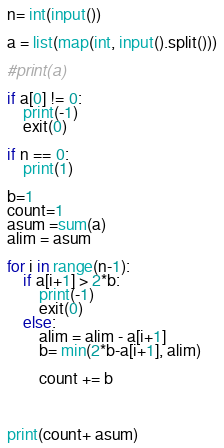Convert code to text. <code><loc_0><loc_0><loc_500><loc_500><_Python_>n= int(input())

a = list(map(int, input().split()))

#print(a)

if a[0] != 0:
    print(-1)
    exit(0)
    
if n == 0:
    print(1)

b=1
count=1
asum =sum(a)
alim = asum

for i in range(n-1):
    if a[i+1] > 2*b:
        print(-1)
        exit(0)
    else:
        alim = alim - a[i+1]
        b= min(2*b-a[i+1], alim)

        count += b



print(count+ asum)</code> 